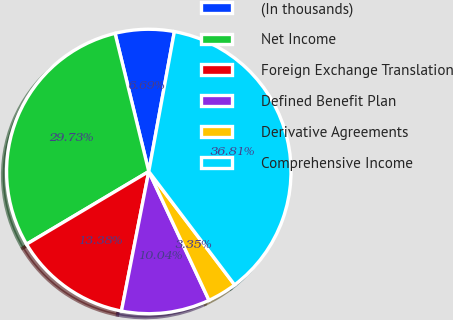Convert chart. <chart><loc_0><loc_0><loc_500><loc_500><pie_chart><fcel>(In thousands)<fcel>Net Income<fcel>Foreign Exchange Translation<fcel>Defined Benefit Plan<fcel>Derivative Agreements<fcel>Comprehensive Income<nl><fcel>6.69%<fcel>29.73%<fcel>13.38%<fcel>10.04%<fcel>3.35%<fcel>36.81%<nl></chart> 